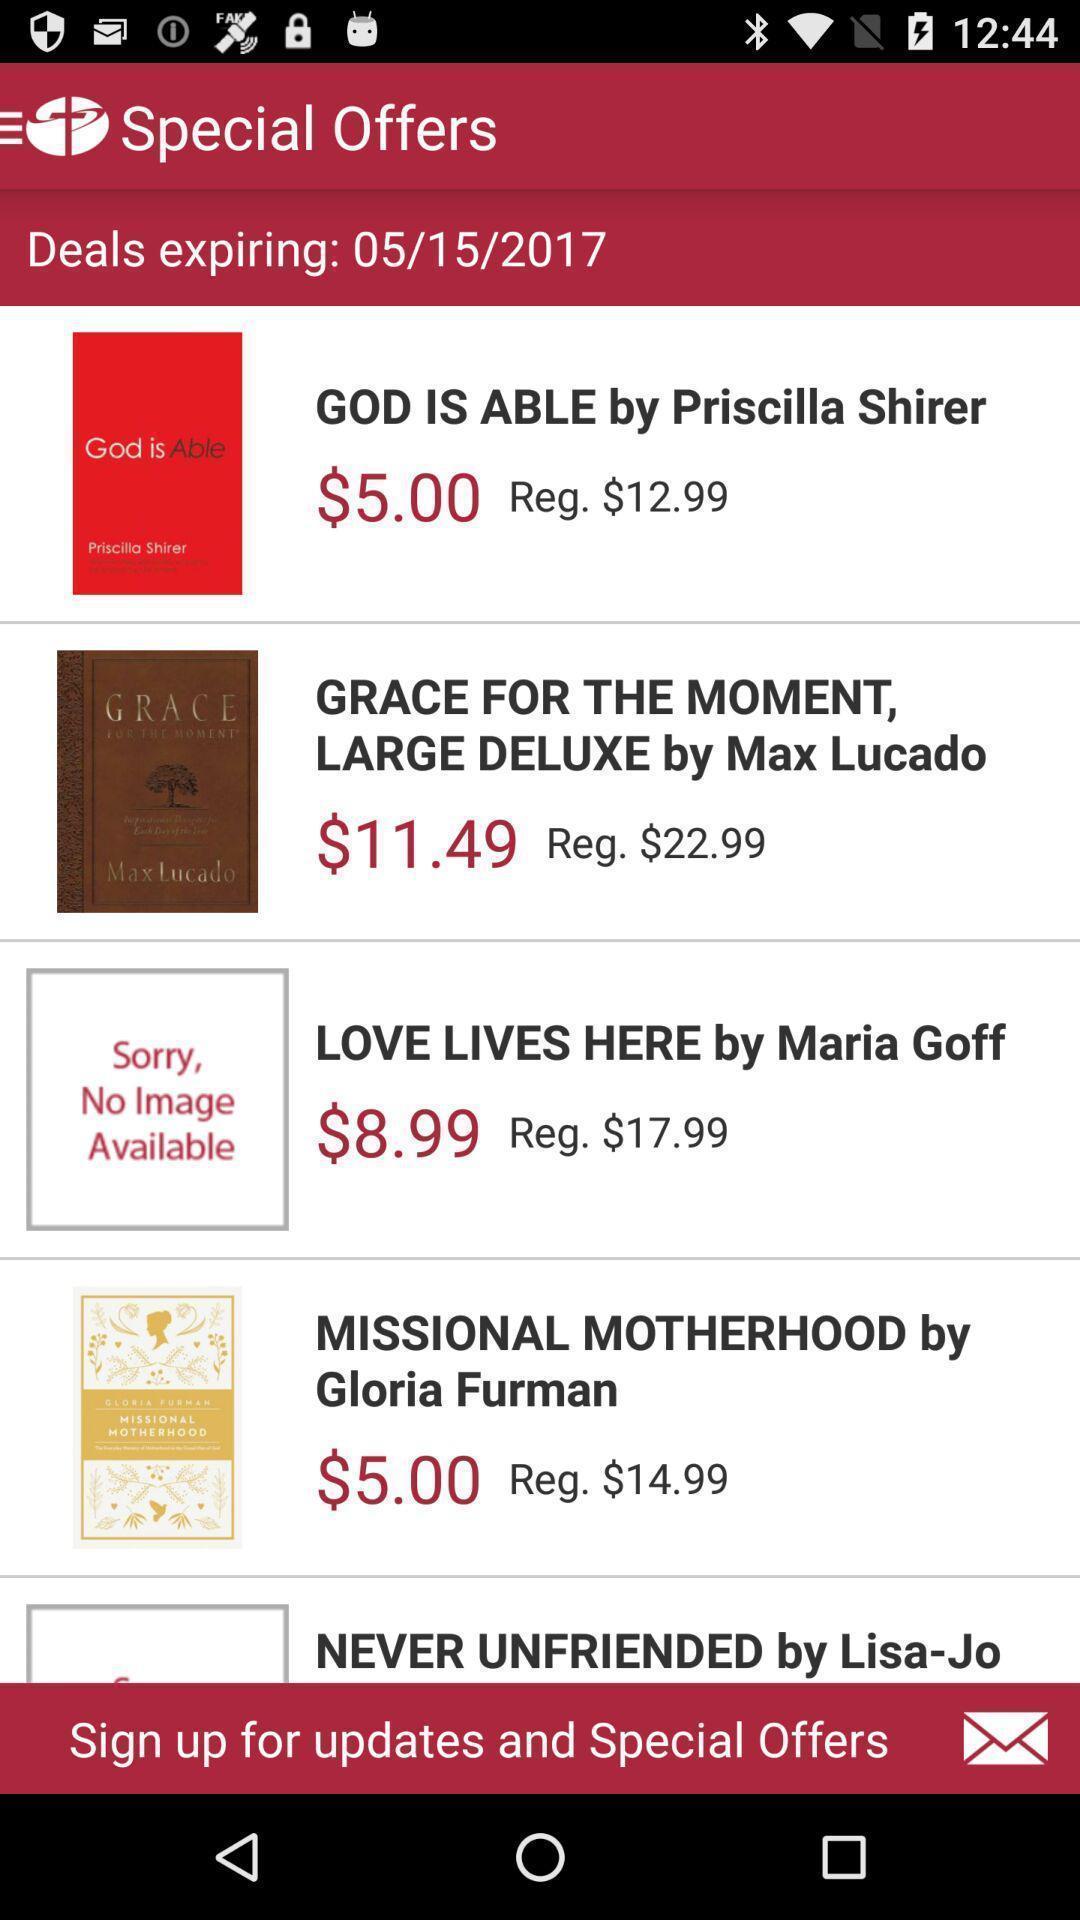What is the overall content of this screenshot? Page showing of different offers available. 